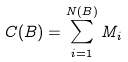Convert formula to latex. <formula><loc_0><loc_0><loc_500><loc_500>C ( B ) = \sum _ { i = 1 } ^ { N ( B ) } M _ { i }</formula> 